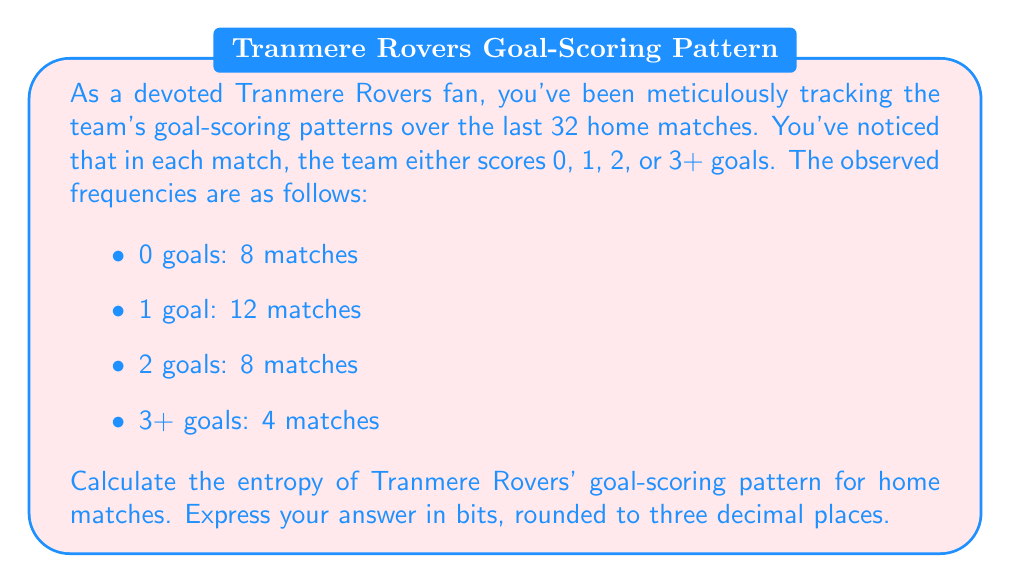Show me your answer to this math problem. To solve this problem, we'll use the entropy formula from information theory:

$$H = -\sum_{i=1}^{n} p_i \log_2(p_i)$$

Where $H$ is the entropy, $p_i$ is the probability of each outcome, and $n$ is the number of possible outcomes.

Step 1: Calculate the probabilities for each outcome.
Total matches = 32
$p(0 \text{ goals}) = 8/32 = 1/4 = 0.25$
$p(1 \text{ goal}) = 12/32 = 3/8 = 0.375$
$p(2 \text{ goals}) = 8/32 = 1/4 = 0.25$
$p(3+ \text{ goals}) = 4/32 = 1/8 = 0.125$

Step 2: Calculate each term in the entropy sum.
$-0.25 \log_2(0.25) = 0.5$
$-0.375 \log_2(0.375) \approx 0.53183$
$-0.25 \log_2(0.25) = 0.5$
$-0.125 \log_2(0.125) \approx 0.37500$

Step 3: Sum all terms to get the entropy.
$H = 0.5 + 0.53183 + 0.5 + 0.37500 = 1.90683$

Step 4: Round to three decimal places.
$H \approx 1.907$ bits
Answer: 1.907 bits 